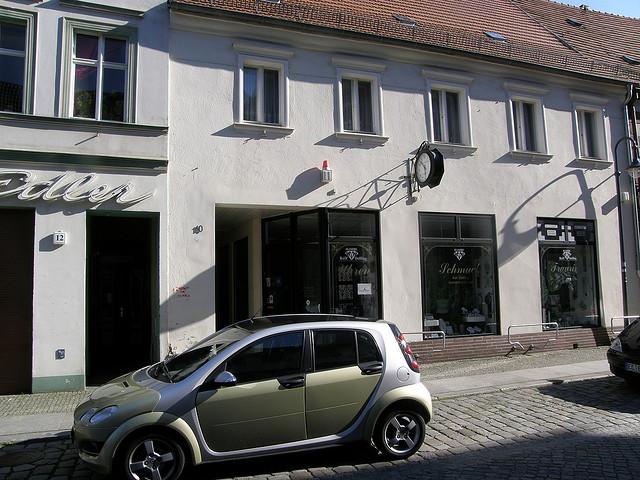What type of roof is on the building?
Keep it brief. Tile. How many air conditioning units are present?
Keep it brief. 0. What color is the building?
Keep it brief. White. How many windows are there?
Be succinct. 10. Is there a person visibly driving this car?
Keep it brief. No. What direction is the car likely to start driving in?
Answer briefly. Left. Is the sloped roof suitable for skiing?
Short answer required. No. 